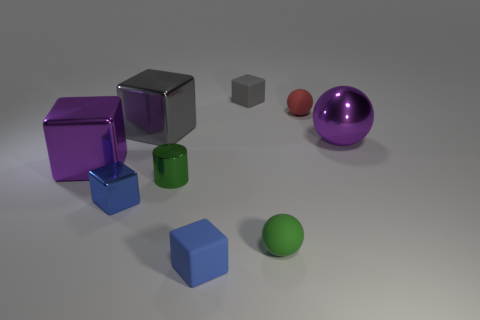The other big shiny object that is the same shape as the big gray thing is what color?
Make the answer very short. Purple. What number of big shiny cubes are there?
Make the answer very short. 2. Does the tiny blue matte thing have the same shape as the large metallic object that is to the left of the small blue shiny object?
Your answer should be compact. Yes. How big is the sphere to the left of the tiny red matte thing?
Your answer should be very brief. Small. What is the material of the red ball?
Give a very brief answer. Rubber. Does the big gray shiny object on the right side of the blue metallic block have the same shape as the blue rubber object?
Make the answer very short. Yes. What size is the object that is the same color as the small shiny cylinder?
Ensure brevity in your answer.  Small. Are there any gray metal things that have the same size as the green matte ball?
Offer a very short reply. No. There is a large block in front of the purple thing right of the large purple metallic cube; are there any green metal things that are behind it?
Your answer should be compact. No. There is a large metallic sphere; is its color the same as the tiny rubber object behind the small red sphere?
Make the answer very short. No. 